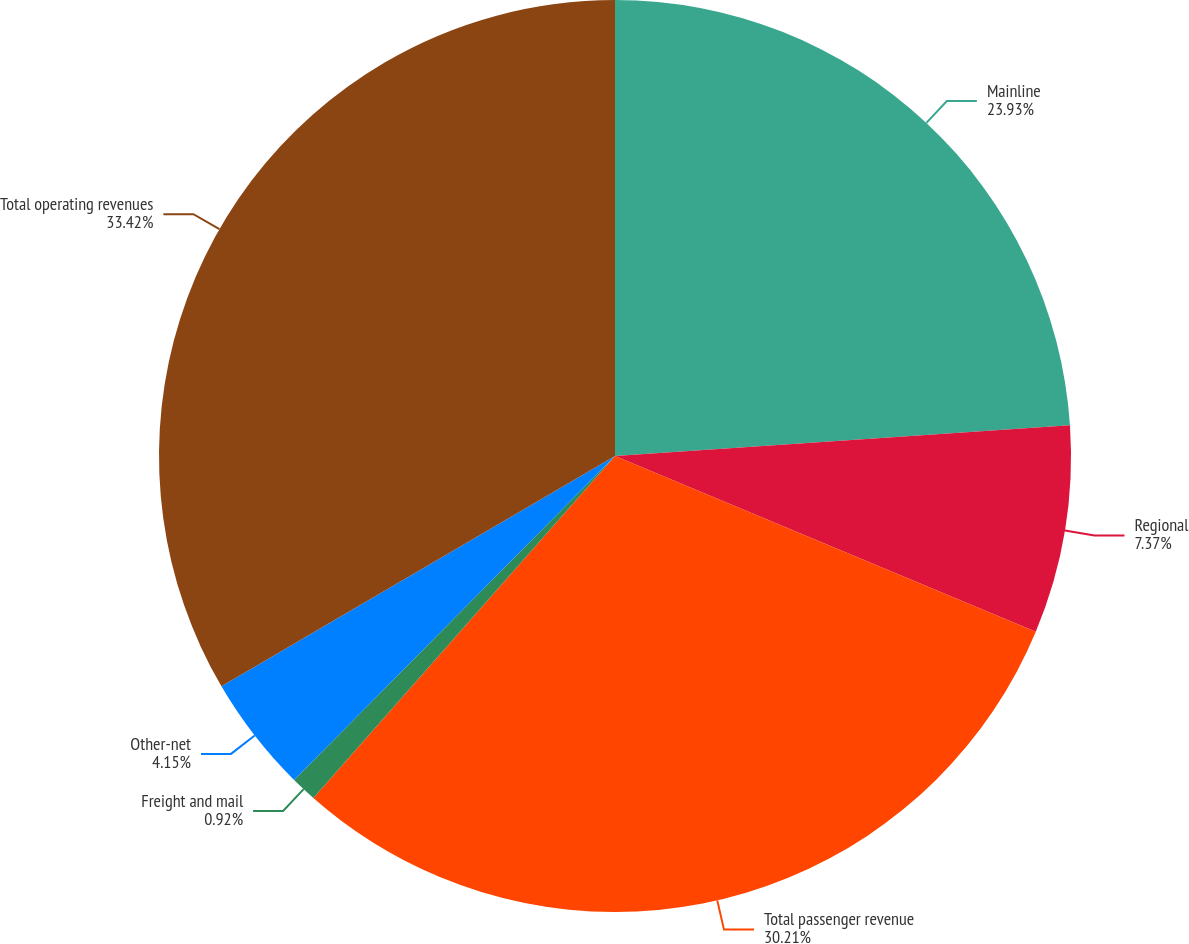<chart> <loc_0><loc_0><loc_500><loc_500><pie_chart><fcel>Mainline<fcel>Regional<fcel>Total passenger revenue<fcel>Freight and mail<fcel>Other-net<fcel>Total operating revenues<nl><fcel>23.93%<fcel>7.37%<fcel>30.21%<fcel>0.92%<fcel>4.15%<fcel>33.43%<nl></chart> 